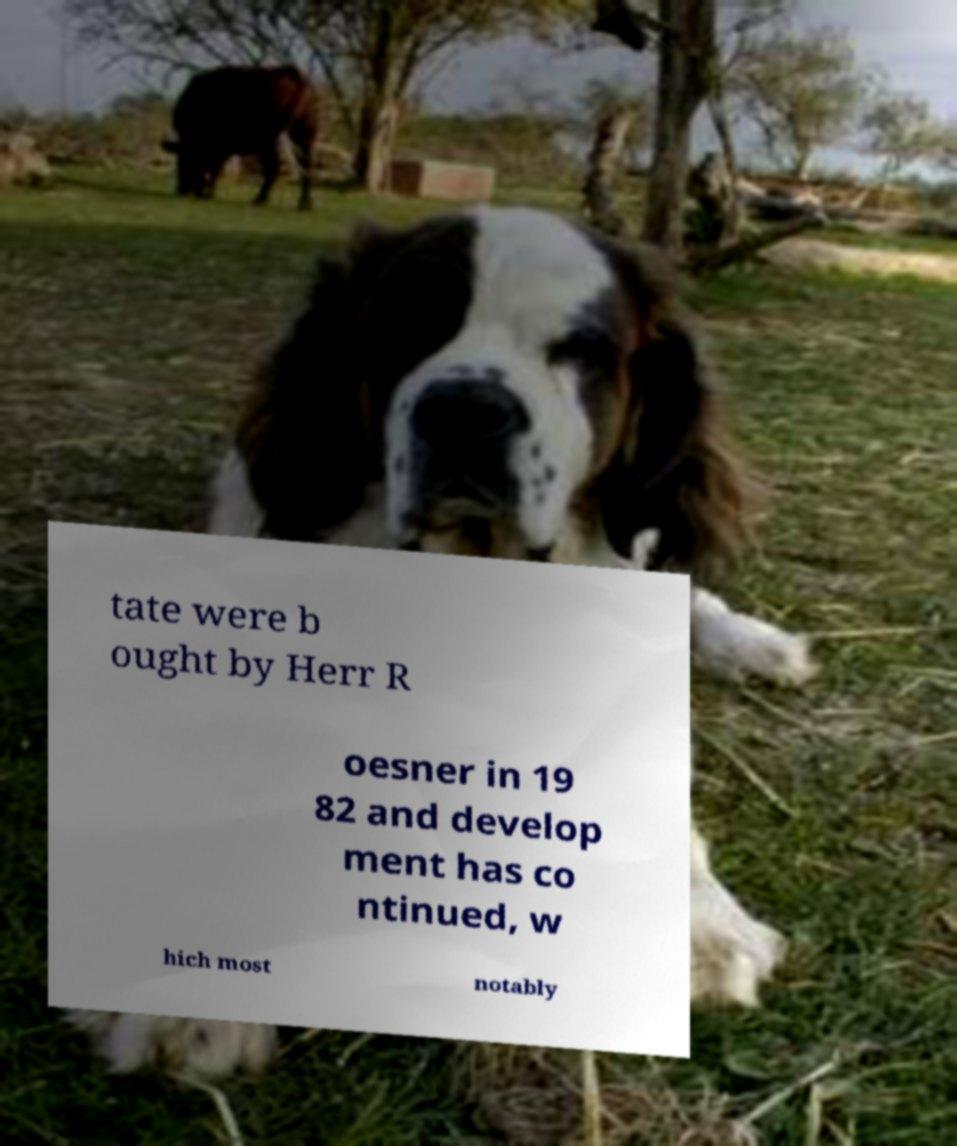What messages or text are displayed in this image? I need them in a readable, typed format. tate were b ought by Herr R oesner in 19 82 and develop ment has co ntinued, w hich most notably 